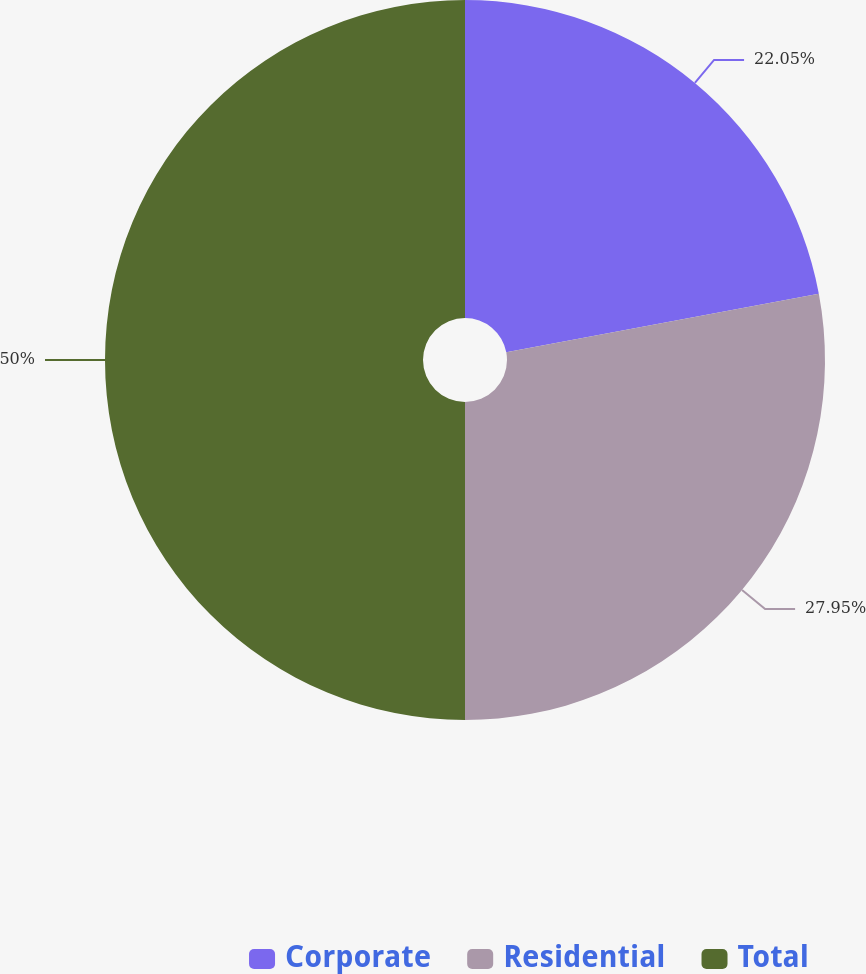<chart> <loc_0><loc_0><loc_500><loc_500><pie_chart><fcel>Corporate<fcel>Residential<fcel>Total<nl><fcel>22.05%<fcel>27.95%<fcel>50.0%<nl></chart> 